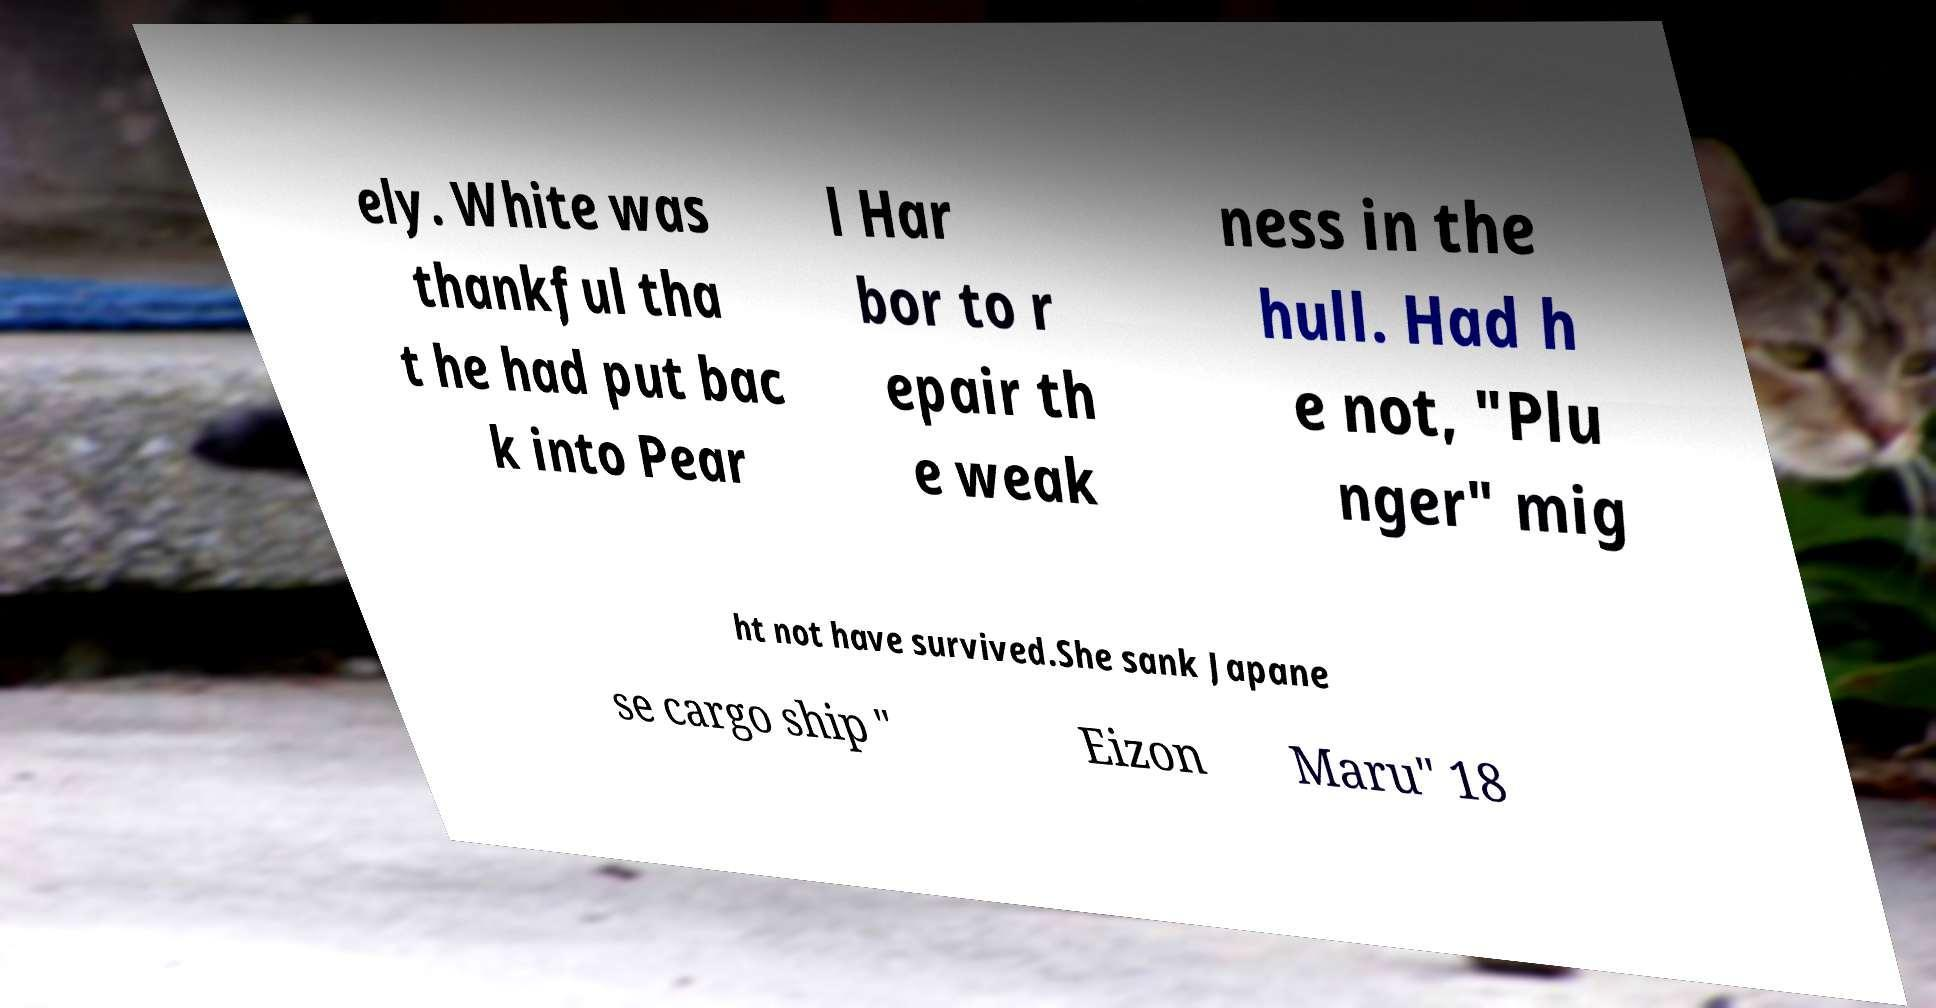There's text embedded in this image that I need extracted. Can you transcribe it verbatim? ely. White was thankful tha t he had put bac k into Pear l Har bor to r epair th e weak ness in the hull. Had h e not, "Plu nger" mig ht not have survived.She sank Japane se cargo ship " Eizon Maru" 18 